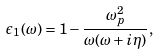<formula> <loc_0><loc_0><loc_500><loc_500>\epsilon _ { 1 } ( \omega ) = 1 - \frac { \omega _ { p } ^ { 2 } } { \omega ( \omega + i \eta ) } ,</formula> 